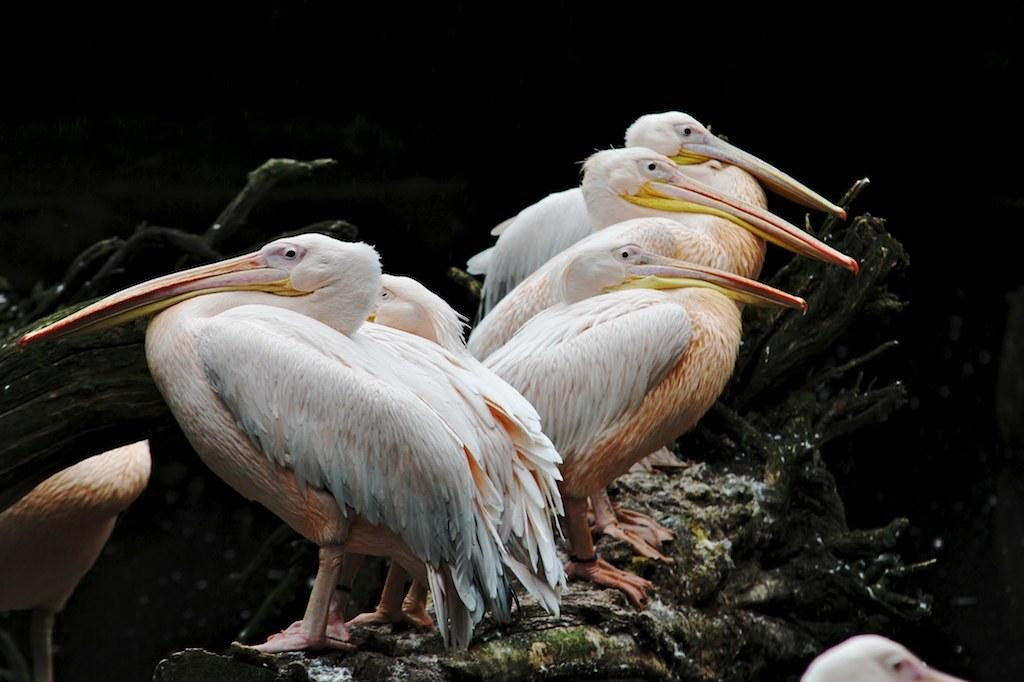What type of animals can be seen in the image? There are white color birds in the image. What else is present in the image besides the birds? There are rocks in the image. Can you describe the lighting in the image? The image is a little dark. Can you tell me how many bags are being carried by the birds in the image? There are no bags present in the image; it features white color birds and rocks. Is there a request being made by the birds in the image? There is no indication of a request being made in the image. 